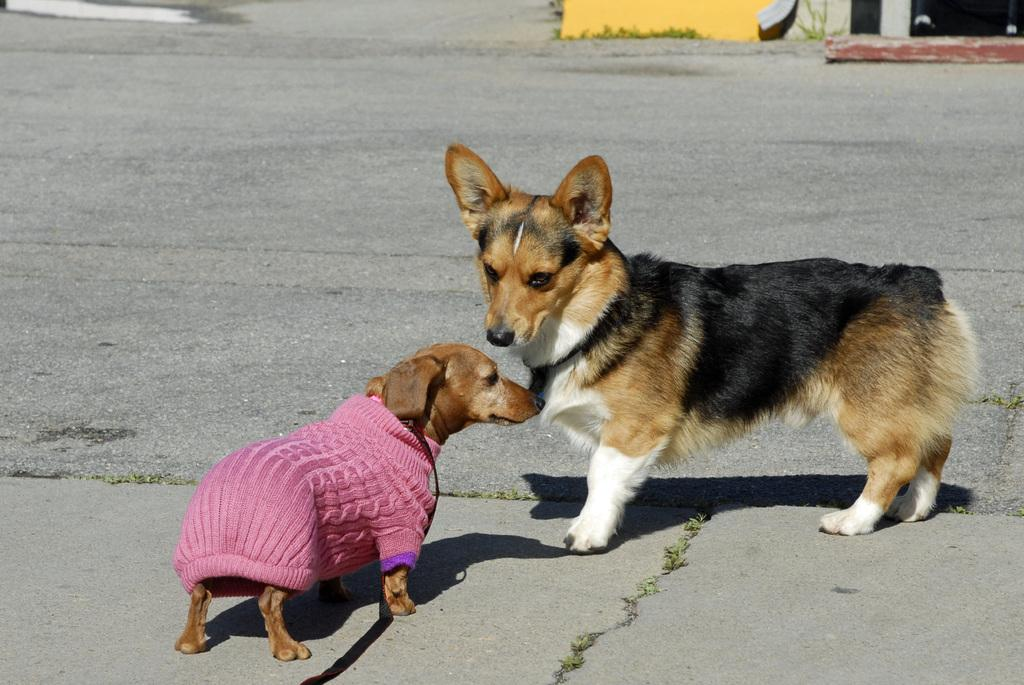What type of animals are present in the image? There are dogs in the image. Can you describe any unique features of the dogs in the image? One of the dogs is wearing a dress. What type of coal is being used to feed the chickens in the image? There are no chickens or coal present in the image; it features dogs, one of which is wearing a dress. 